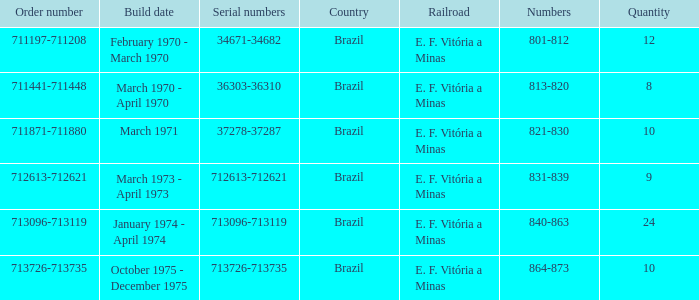Give me the full table as a dictionary. {'header': ['Order number', 'Build date', 'Serial numbers', 'Country', 'Railroad', 'Numbers', 'Quantity'], 'rows': [['711197-711208', 'February 1970 - March 1970', '34671-34682', 'Brazil', 'E. F. Vitória a Minas', '801-812', '12'], ['711441-711448', 'March 1970 - April 1970', '36303-36310', 'Brazil', 'E. F. Vitória a Minas', '813-820', '8'], ['711871-711880', 'March 1971', '37278-37287', 'Brazil', 'E. F. Vitória a Minas', '821-830', '10'], ['712613-712621', 'March 1973 - April 1973', '712613-712621', 'Brazil', 'E. F. Vitória a Minas', '831-839', '9'], ['713096-713119', 'January 1974 - April 1974', '713096-713119', 'Brazil', 'E. F. Vitória a Minas', '840-863', '24'], ['713726-713735', 'October 1975 - December 1975', '713726-713735', 'Brazil', 'E. F. Vitória a Minas', '864-873', '10']]} What are the numerical values for the order numbers ranging from 713096 to 713119? 840-863. 